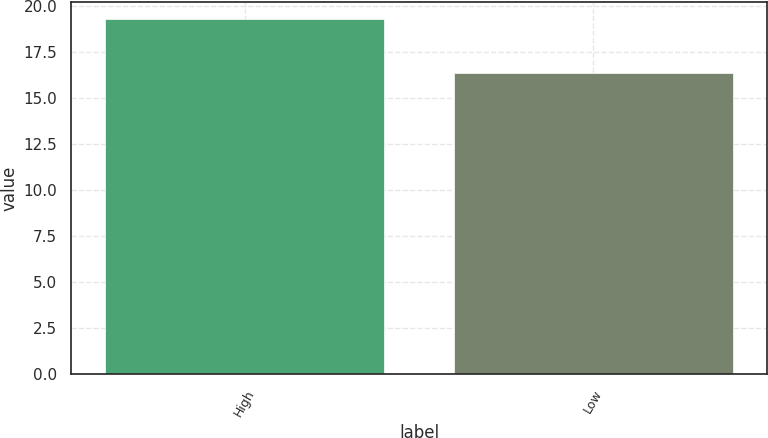<chart> <loc_0><loc_0><loc_500><loc_500><bar_chart><fcel>High<fcel>Low<nl><fcel>19.29<fcel>16.36<nl></chart> 